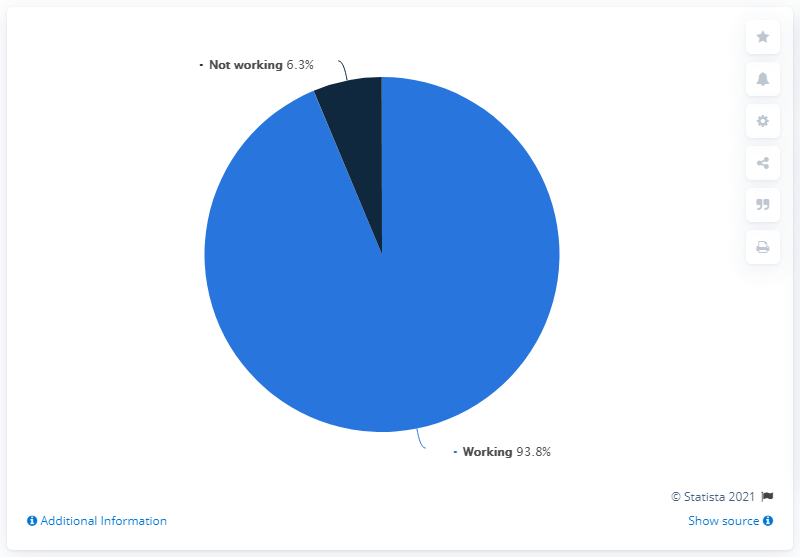Point out several critical features in this image. The highest value is 93.8... The ratio of working time to non-working time is 14.89... 